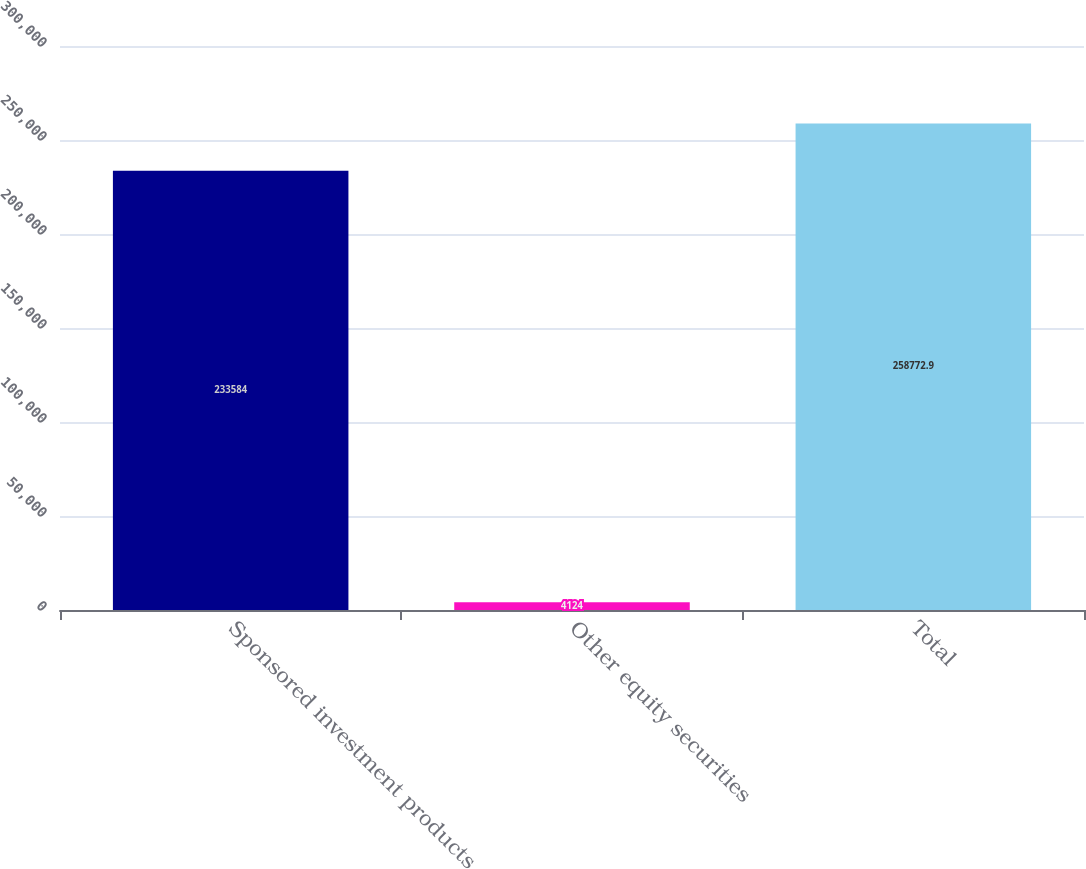Convert chart. <chart><loc_0><loc_0><loc_500><loc_500><bar_chart><fcel>Sponsored investment products<fcel>Other equity securities<fcel>Total<nl><fcel>233584<fcel>4124<fcel>258773<nl></chart> 